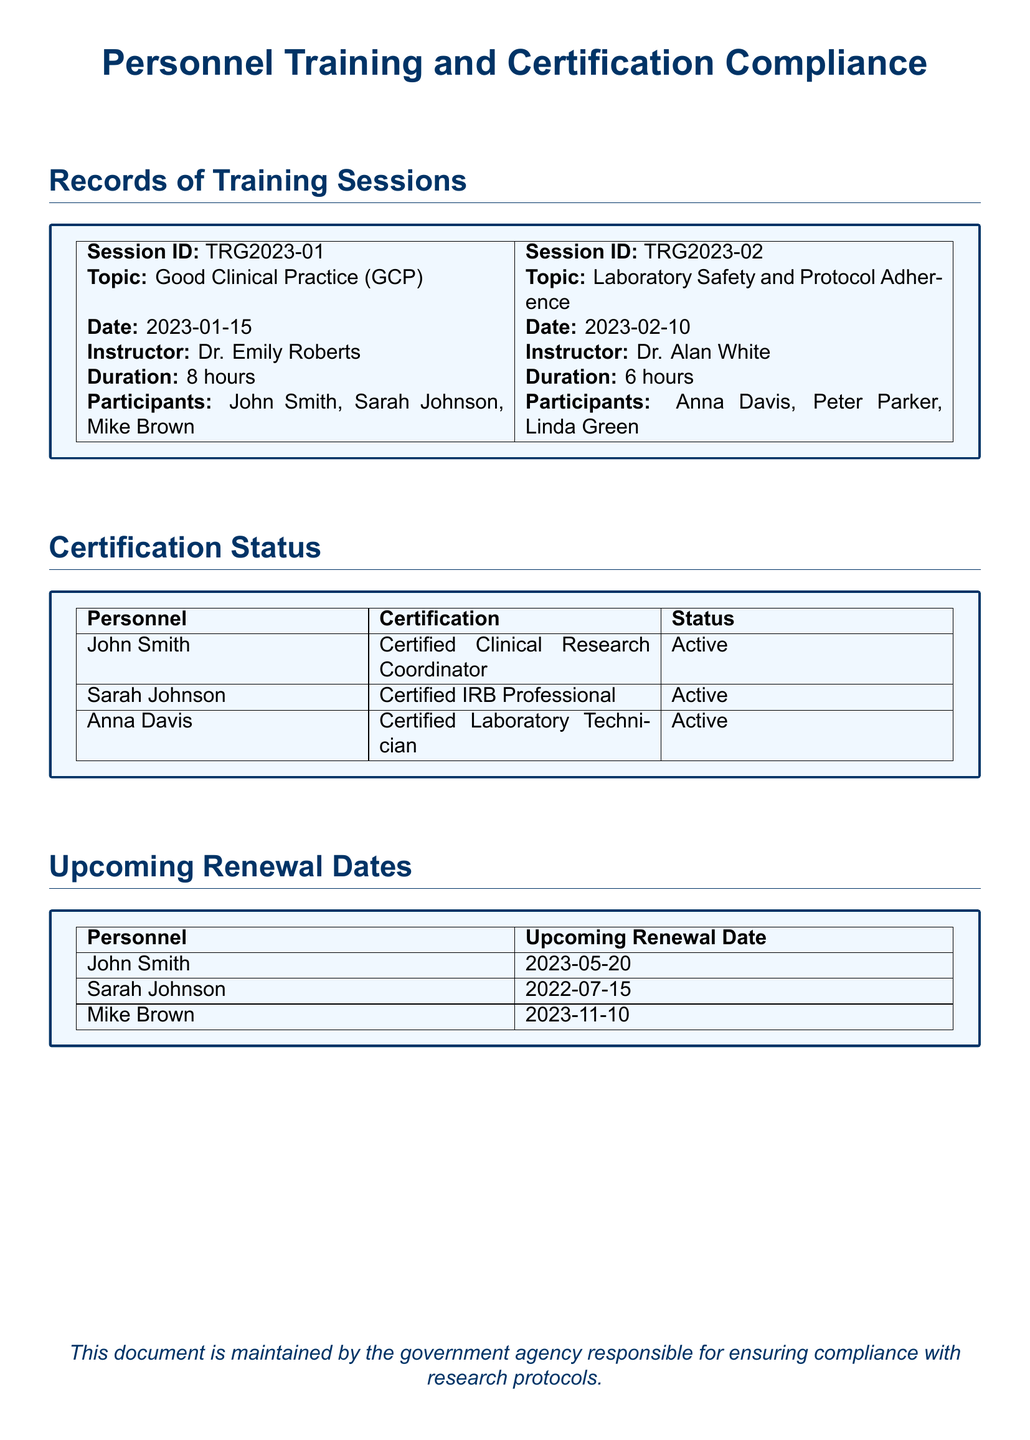What was the date of the GCP training session? The document specifies that the Good Clinical Practice training session took place on January 15, 2023.
Answer: 2023-01-15 Who was the instructor for the Laboratory Safety session? According to the document, Dr. Alan White led the Laboratory Safety and Protocol Adherence session.
Answer: Dr. Alan White What is the certification status of Sarah Johnson? The document indicates that Sarah Johnson holds an active certification status as a Certified IRB Professional.
Answer: Active When is John Smith's upcoming renewal date? The document lists John's upcoming renewal date as May 20, 2023.
Answer: 2023-05-20 How long did the GCP training session last? The document states that the duration of the GCP training session was 8 hours.
Answer: 8 hours Which personnel member is due for renewal in November 2023? The document mentions that Mike Brown has an upcoming renewal date in November 2023.
Answer: Mike Brown What topic was covered in the session led by Dr. Emily Roberts? The document notes that Dr. Emily Roberts covered the Good Clinical Practice topic during her training session.
Answer: Good Clinical Practice How many participants were there in the Laboratory Safety training session? The document shows that there were three participants in the Laboratory Safety and Protocol Adherence session.
Answer: 3 What is the certification of Anna Davis? The document states that Anna Davis is a Certified Laboratory Technician.
Answer: Certified Laboratory Technician 